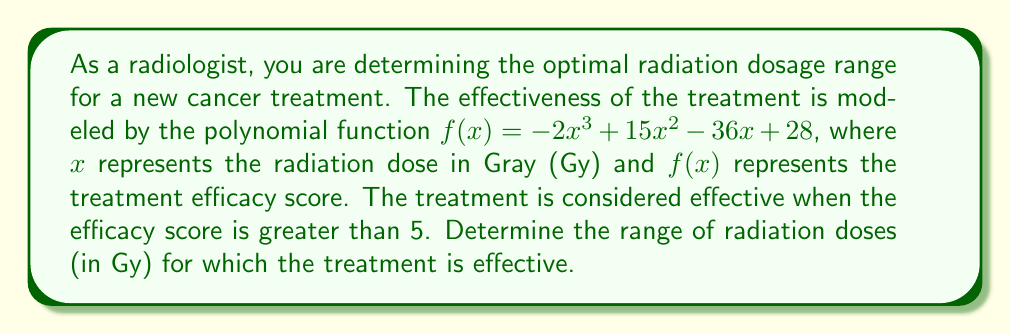Could you help me with this problem? To solve this problem, we need to find the range of $x$ values for which $f(x) > 5$. Let's approach this step-by-step:

1) First, we set up the inequality:
   $-2x^3 + 15x^2 - 36x + 28 > 5$

2) Rearrange the inequality:
   $-2x^3 + 15x^2 - 36x + 23 > 0$

3) Factor the left side of the inequality:
   $-(2x^3 - 15x^2 + 36x - 23) > 0$
   $-(x-1)(2x^2-13x+23) > 0$

4) For this inequality to be true, the expression inside the parentheses must be negative (because of the negative sign outside).

5) Solve $(x-1)(2x^2-13x+23) < 0$

6) Find the roots of each factor:
   $x-1 = 0$ gives $x = 1$
   $2x^2-13x+23 = 0$ gives $x = \frac{13 \pm \sqrt{169-184}}{4} = \frac{13 \pm \sqrt{-15}}{4}$
   The quadratic has no real roots.

7) Since the quadratic factor always has the same sign (positive, as the coefficient of $x^2$ is positive), the sign of the whole expression changes only at $x = 1$.

8) Test points:
   For $x < 1$, $(x-1) < 0$ and $(2x^2-13x+23) > 0$, so the product is negative.
   For $x > 1$, $(x-1) > 0$ and $(2x^2-13x+23) > 0$, so the product is positive.

9) Therefore, the original inequality is satisfied when $x < 1$.
Answer: The treatment is effective for radiation doses less than 1 Gy, i.e., $x \in (0, 1)$ Gy. 